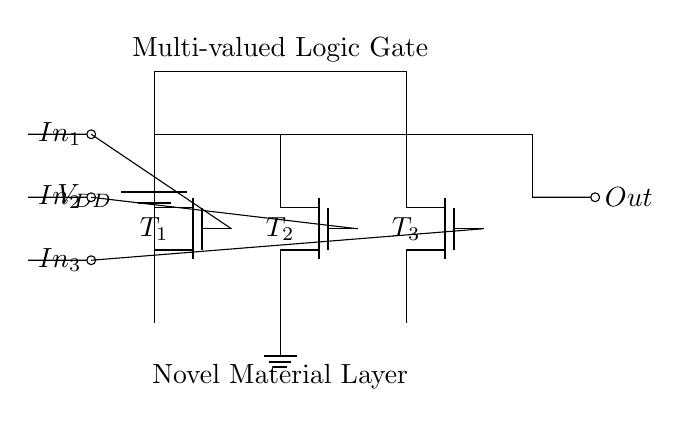What is the type of the logic gate represented? The circuit shows three NMOS transistors working together as a multi-valued logic gate. The use of multiple inputs indicates a logic function that can handle more than binary values.
Answer: Multi-valued logic gate How many transistors are present in the circuit? The diagram shows three NMOS transistors labeled as T1, T2, and T3. Each one corresponds to one of the inputs.
Answer: Three What are the input names for this circuit? The inputs are represented by labels In1, In2, and In3 which correspond to the control gates of the NMOS transistors.
Answer: In1, In2, In3 What is the output voltage source in this circuit? The output node is connected to ground through the NMOS devices, which means the output will be either pulled high or low based on the transistors’ states. The presence of VDD indicates power supply management.
Answer: VDD What is the operating principle of the transistors used? NMOS transistors are used here, which operate by allowing current to flow when a voltage is applied to the gate terminal. The circuit depends on the gate control voltages provided by the inputs.
Answer: Voltage-controlled What is the representation of the ground in the circuit? The circuit includes a ground label connected to the lowest point of the NMOS transistors, indicating the reference point for the circuit operation. This connection ensures that any voltage measurements are referenced accurately.
Answer: Ground How does this circuit achieve ultra-low power operation? The ultra-low power characteristic is attributed to the novel materials used for the NMOS transistors, which allows them to operate efficiently with lower voltage thresholds, leading to reduced power consumption.
Answer: Novel materials 